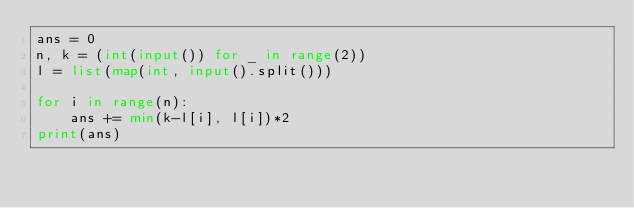<code> <loc_0><loc_0><loc_500><loc_500><_Python_>ans = 0
n, k = (int(input()) for _ in range(2))
l = list(map(int, input().split()))

for i in range(n):
    ans += min(k-l[i], l[i])*2
print(ans)</code> 